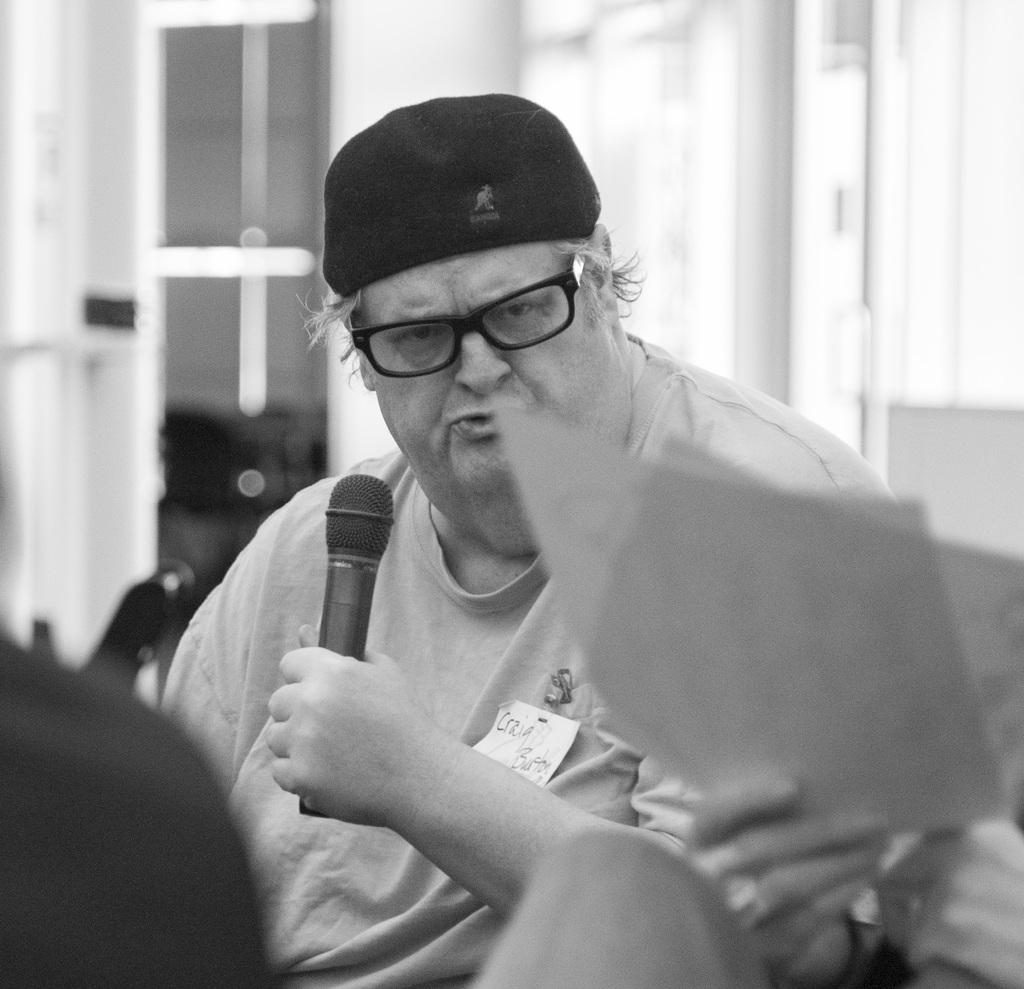What is the person in the image wearing on their head? The person in the image is wearing a cap. What is the person holding in their hand? The person is holding a microphone. What is the other person holding in the image? The other person is holding papers. What architectural feature can be seen in the image? There is a door visible in the image. How is the image presented in terms of color? The image is black and white. Can you see any ghosts interacting with the person holding the microphone in the image? No, there are no ghosts present in the image. What type of cooking utensil is the cook using in the image? There is no cook or cooking utensil present in the image. 